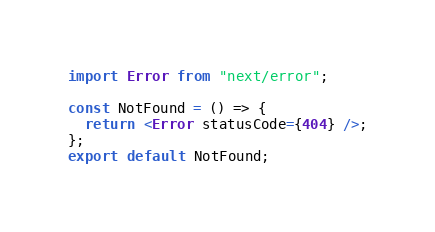<code> <loc_0><loc_0><loc_500><loc_500><_TypeScript_>import Error from "next/error";

const NotFound = () => {
  return <Error statusCode={404} />;
};
export default NotFound;
</code> 